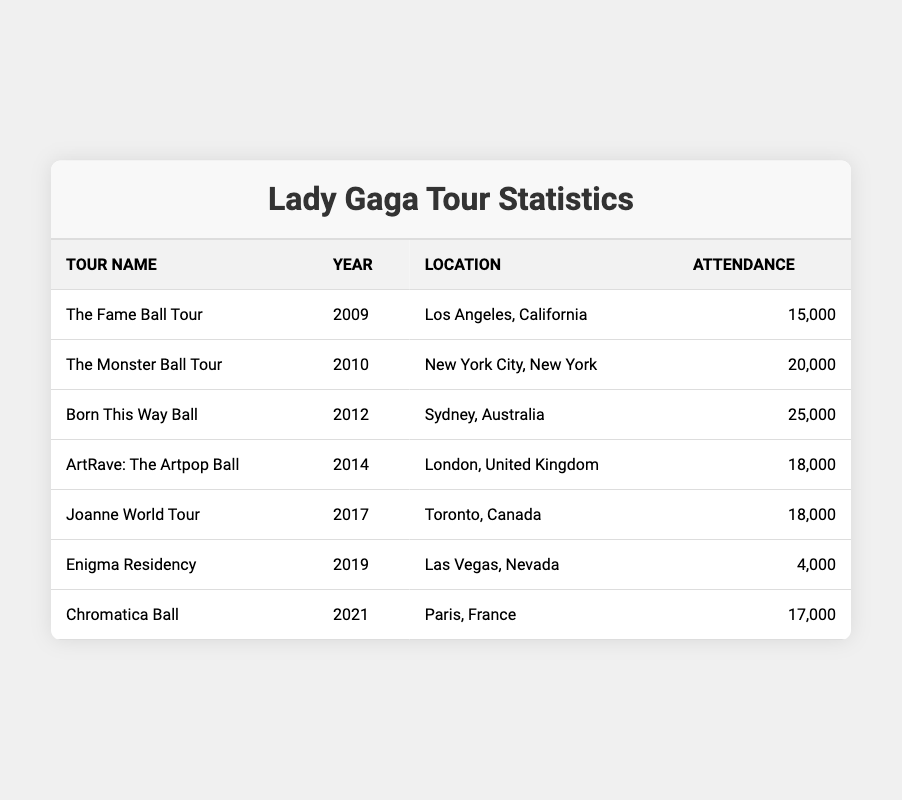What was the attendance for the Born This Way Ball tour? The table shows that the attendance for the Born This Way Ball tour in 2012 was 25,000.
Answer: 25,000 Which tour took place in 2014? According to the table, the ArtRave: The Artpop Ball tour took place in 2014.
Answer: ArtRave: The Artpop Ball How many tours had an attendance of 18,000? By reviewing the table, both the ArtRave: The Artpop Ball tour in 2014 and the Joanne World Tour in 2017 had an attendance of 18,000. Thus, there are 2 tours with that attendance.
Answer: 2 What is the total attendance of all the tours listed? To find the total attendance, sum up the attendances: (15,000 + 20,000 + 25,000 + 18,000 + 18,000 + 4,000 + 17,000) = 117,000.
Answer: 117,000 Which tour had the lowest attendance? The table indicates that the Enigma Residency tour in 2019 had the lowest attendance of 4,000.
Answer: Enigma Residency What is the average attendance across all the tours? To calculate the average attendance, first sum the total attendance (117,000) and then divide by the number of tours (7): 117,000 / 7 = 16,714.
Answer: 16,714 Was the attendance for the Chromatica Ball higher than that for the Joanne World Tour? By comparing the two attendances listed in the table, the Chromatica Ball had an attendance of 17,000, while the Joanne World Tour had 18,000, making the statement false.
Answer: No How many tours were held in North America? From the table, The Fame Ball Tour (Los Angeles), The Monster Ball Tour (New York), Joanne World Tour (Toronto), and Enigma Residency (Las Vegas) are all tours in North America, totaling 4 tours.
Answer: 4 Did Lady Gaga perform more in large venues with over 20,000 attendance than in smaller venues with less than 10,000? The table indicates two tours had over 20,000 (Born This Way Ball with 25,000 and Monster Ball with 20,000) and one tour had under 10,000 (Enigma Residency with 4,000). Therefore, Lady Gaga performed in more large venues.
Answer: Yes What percentage of the total attendance does the Born This Way Ball represent? First, determine the percentage by using the Born This Way Ball attendance (25,000) and the total attendance (117,000): (25,000 / 117,000) * 100 = 21.37%.
Answer: 21.37% 